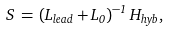Convert formula to latex. <formula><loc_0><loc_0><loc_500><loc_500>S \, = \, ( L _ { l e a d } + L _ { 0 } ) ^ { - 1 } \, H _ { h y b } ,</formula> 